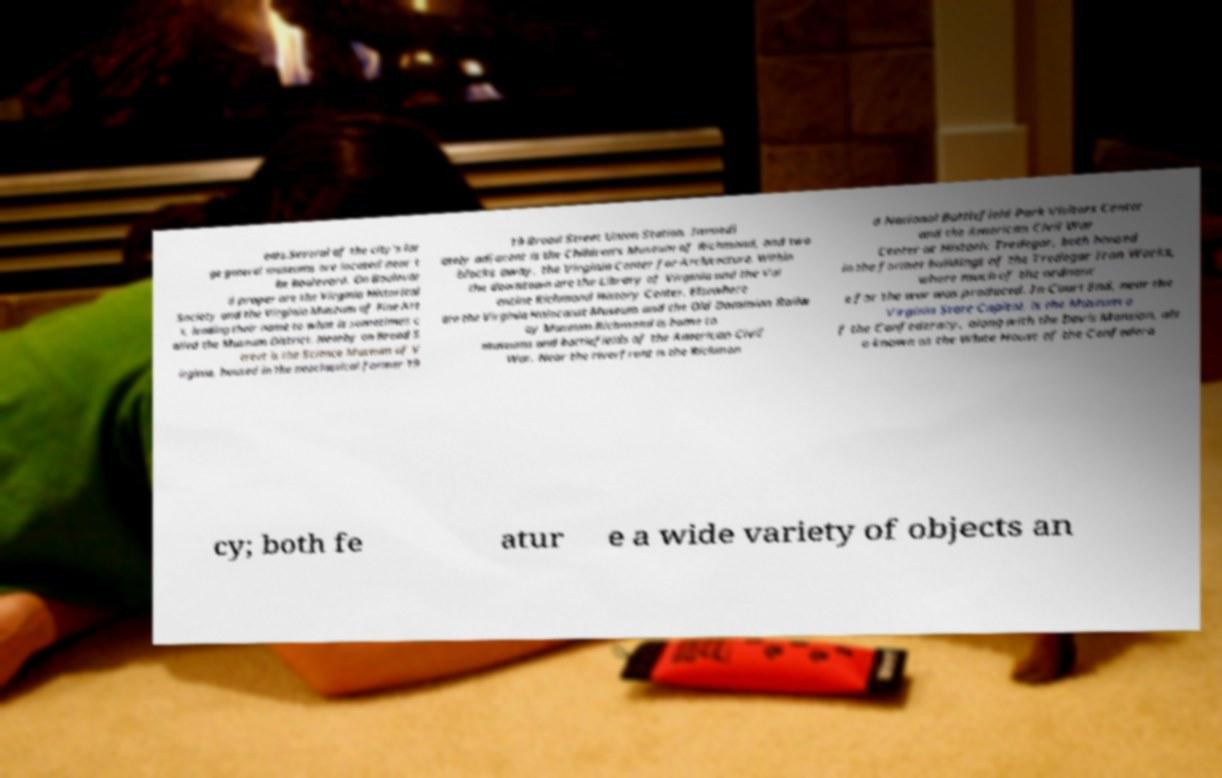Could you assist in decoding the text presented in this image and type it out clearly? ents.Several of the city's lar ge general museums are located near t he Boulevard. On Boulevar d proper are the Virginia Historical Society and the Virginia Museum of Fine Art s, lending their name to what is sometimes c alled the Museum District. Nearby on Broad S treet is the Science Museum of V irginia, housed in the neoclassical former 19 19 Broad Street Union Station. Immedi ately adjacent is the Children's Museum of Richmond, and two blocks away, the Virginia Center for Architecture. Within the downtown are the Library of Virginia and the Val entine Richmond History Center. Elsewhere are the Virginia Holocaust Museum and the Old Dominion Railw ay Museum.Richmond is home to museums and battlefields of the American Civil War. Near the riverfront is the Richmon d National Battlefield Park Visitors Center and the American Civil War Center at Historic Tredegar, both housed in the former buildings of the Tredegar Iron Works, where much of the ordnanc e for the war was produced. In Court End, near the Virginia State Capitol, is the Museum o f the Confederacy, along with the Davis Mansion, als o known as the White House of the Confedera cy; both fe atur e a wide variety of objects an 